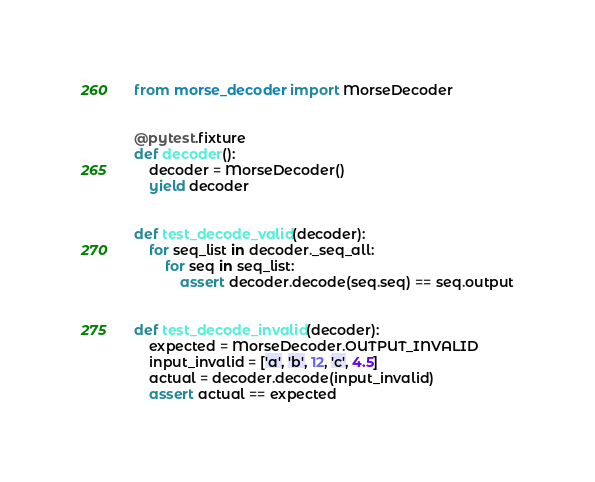Convert code to text. <code><loc_0><loc_0><loc_500><loc_500><_Python_>from morse_decoder import MorseDecoder


@pytest.fixture
def decoder():
    decoder = MorseDecoder()
    yield decoder


def test_decode_valid(decoder):
    for seq_list in decoder._seq_all:
        for seq in seq_list:
            assert decoder.decode(seq.seq) == seq.output


def test_decode_invalid(decoder):
    expected = MorseDecoder.OUTPUT_INVALID
    input_invalid = ['a', 'b', 12, 'c', 4.5]
    actual = decoder.decode(input_invalid)
    assert actual == expected
</code> 